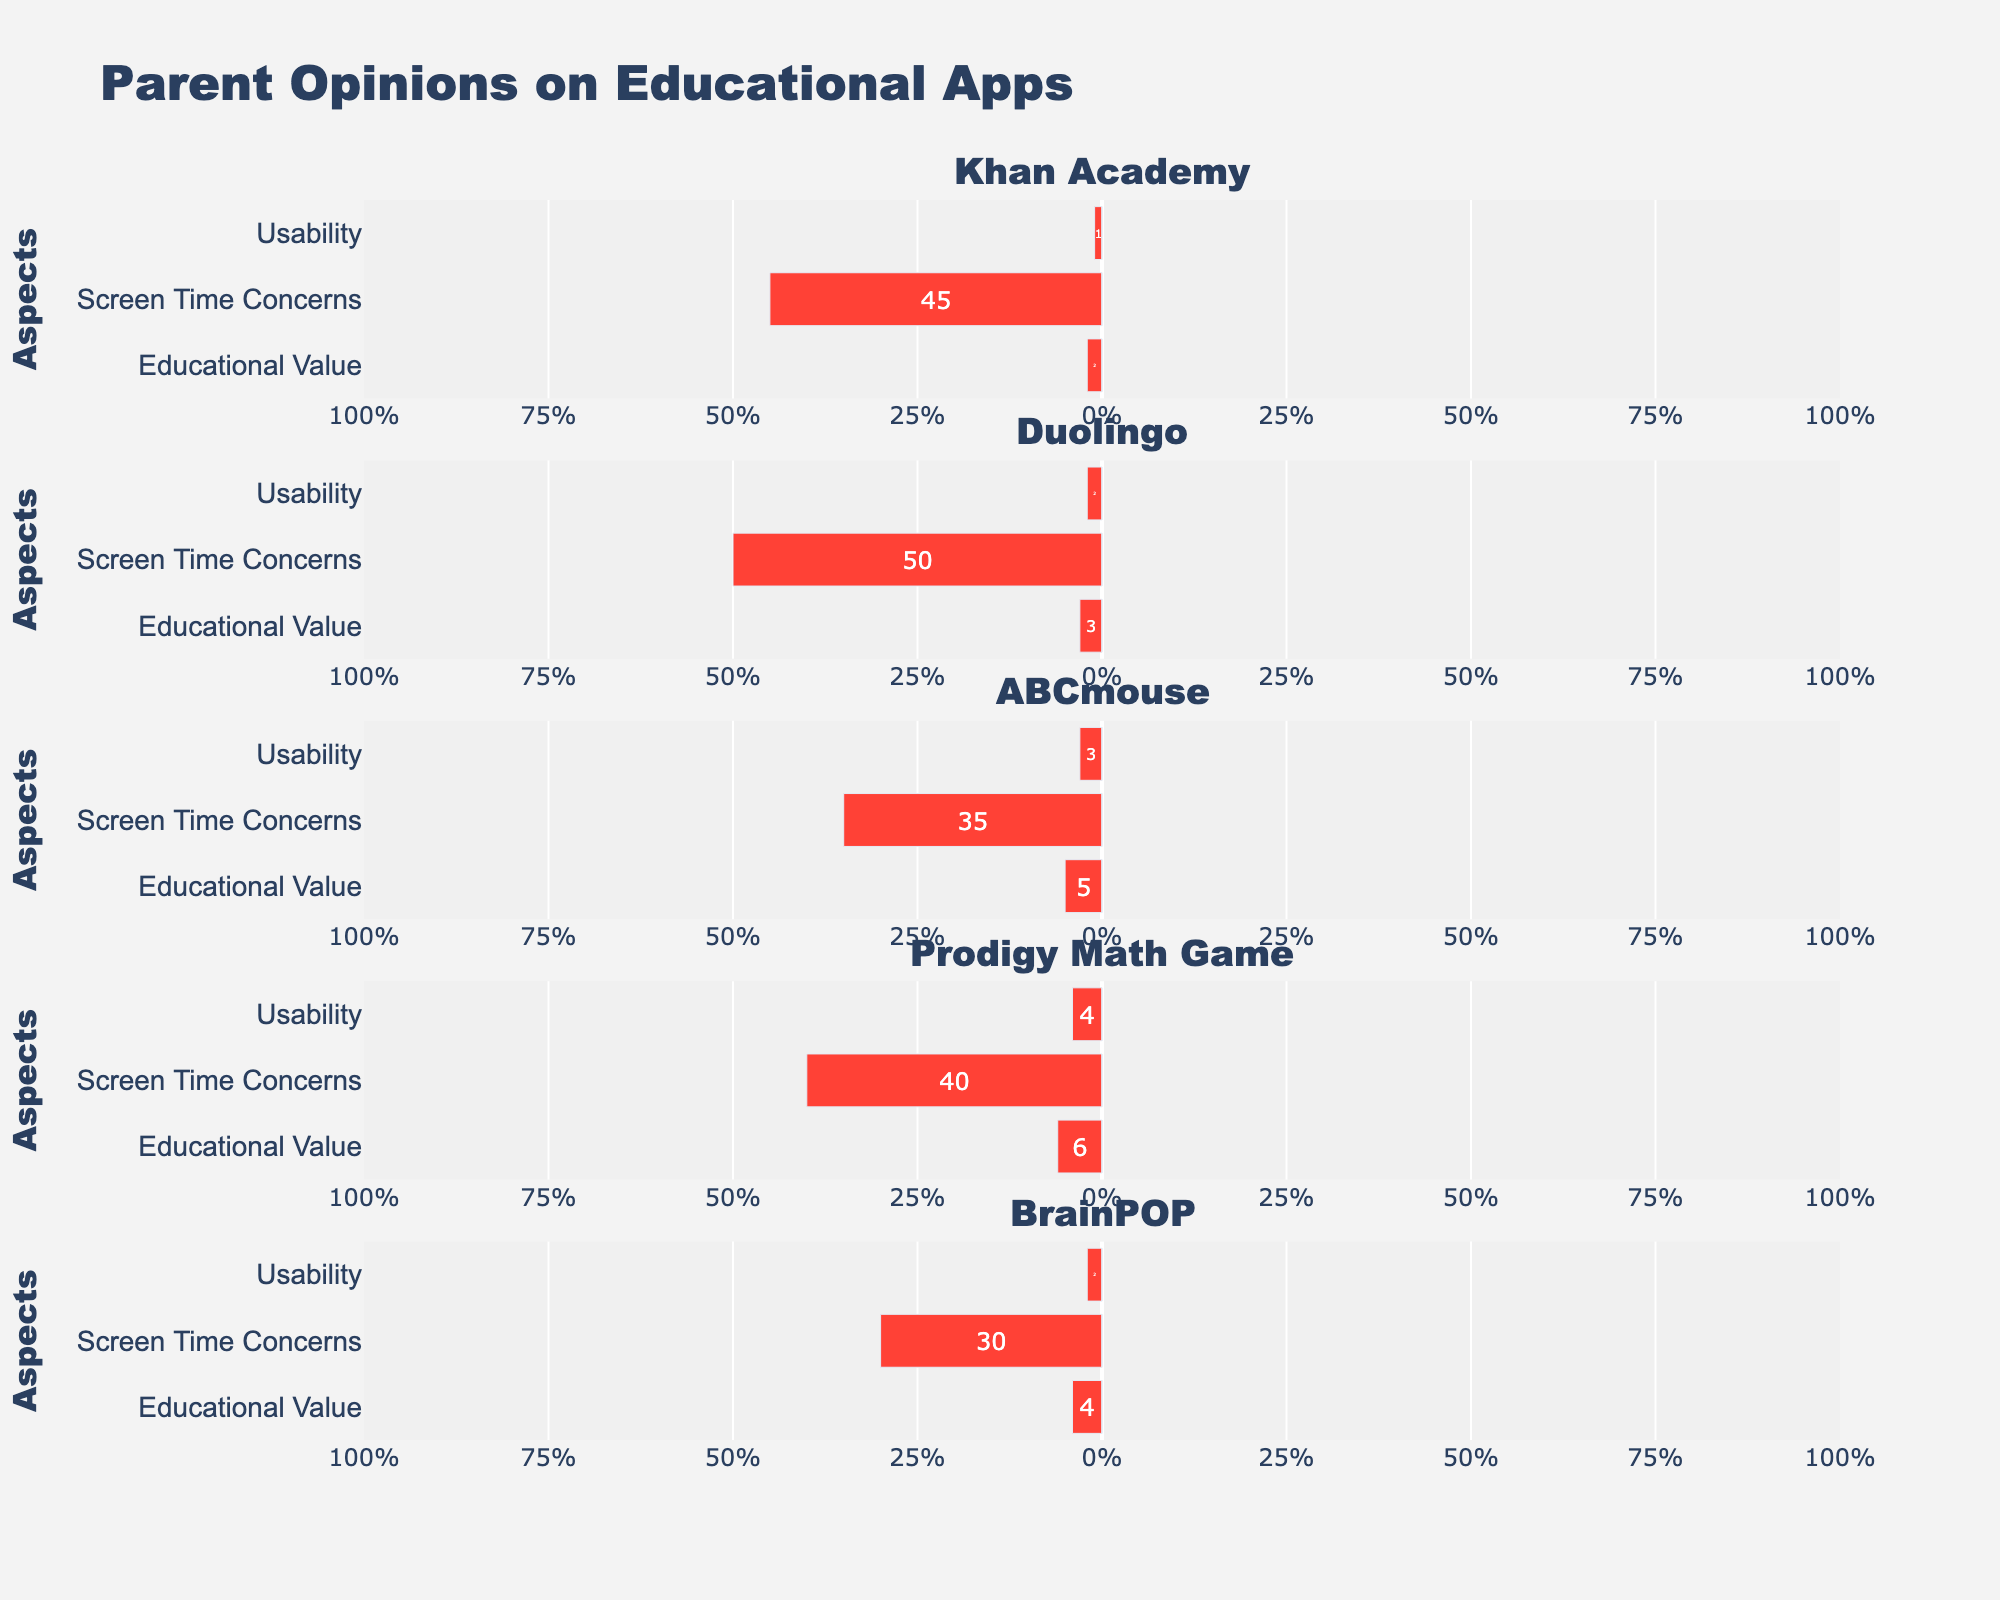what are the top two apps parents agree have the most educational value? The figure shows the bar lengths for the 'Educational Value' aspect of each app, with 'Agree' and 'Strongly Agree' categories combined. Count the positive sides: Khan Academy's bars add up to 85%, and Duolingo's bars add up to 75%, making them the top two.
Answer: Khan Academy, Duolingo which app has the highest percentage of parents agreeing on its usability? Look at the 'Usability' aspect for each app and compare the 'Agree' and 'Strongly Agree' sections. Khan Academy has the highest total with 85%.
Answer: Khan Academy do parents have more screen time concerns for ABCmouse or BrainPOP? Compare the lengths of the 'Screen Time Concerns' negative bars. ABCmouse has more significant negative sections overall than BrainPOP.
Answer: ABCmouse how does the percentage of parents agreeable about Khan Academy's educational value compare to Prodigy Math Game? Compare the 'Agree' and 'Strongly Agree' bars for the 'Educational Value'. Khan Academy has 85% while Prodigy Math Game has 68%.
Answer: Khan Academy is higher which aspect of Duolingo has the most balanced opinion among parents? 'Balanced' means closer to the middle values. For Duolingo, 'Usability' has fewer extreme values and more Neutral and Agree.
Answer: Usability what is the average percentage of parents who strongly agree on the educational value of the apps? Extract the Strongly Agree percentages for 'Educational Value' of each app and calculate the average. (50% + 46% + 40% + 50% + 44%) / 5 = 46% average
Answer: 46% which app has the least disagreement about its usability? Examine 'Usability' for all apps and look at the 'Strongly Disagree' and 'Disagree' bars. Khan Academy has the least with a combined total of 5%.
Answer: Khan Academy does Khan Academy or Duolingo have higher neutral opinions on screen time concerns? Compare the fraction of 'Neutral' under 'Screen Time Concerns'. Both Khan Academy and Duolingo show 15%.
Answer: Equal 